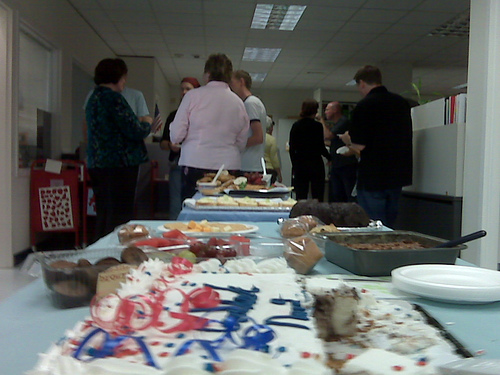<image>Did everyone contribute food? I don't know if everyone contributed food. The responses vary from 'yes', 'maybe', to 'no'. Did everyone contribute food? I don't know if everyone contributed food. Some say yes, some say no, and some say maybe. 